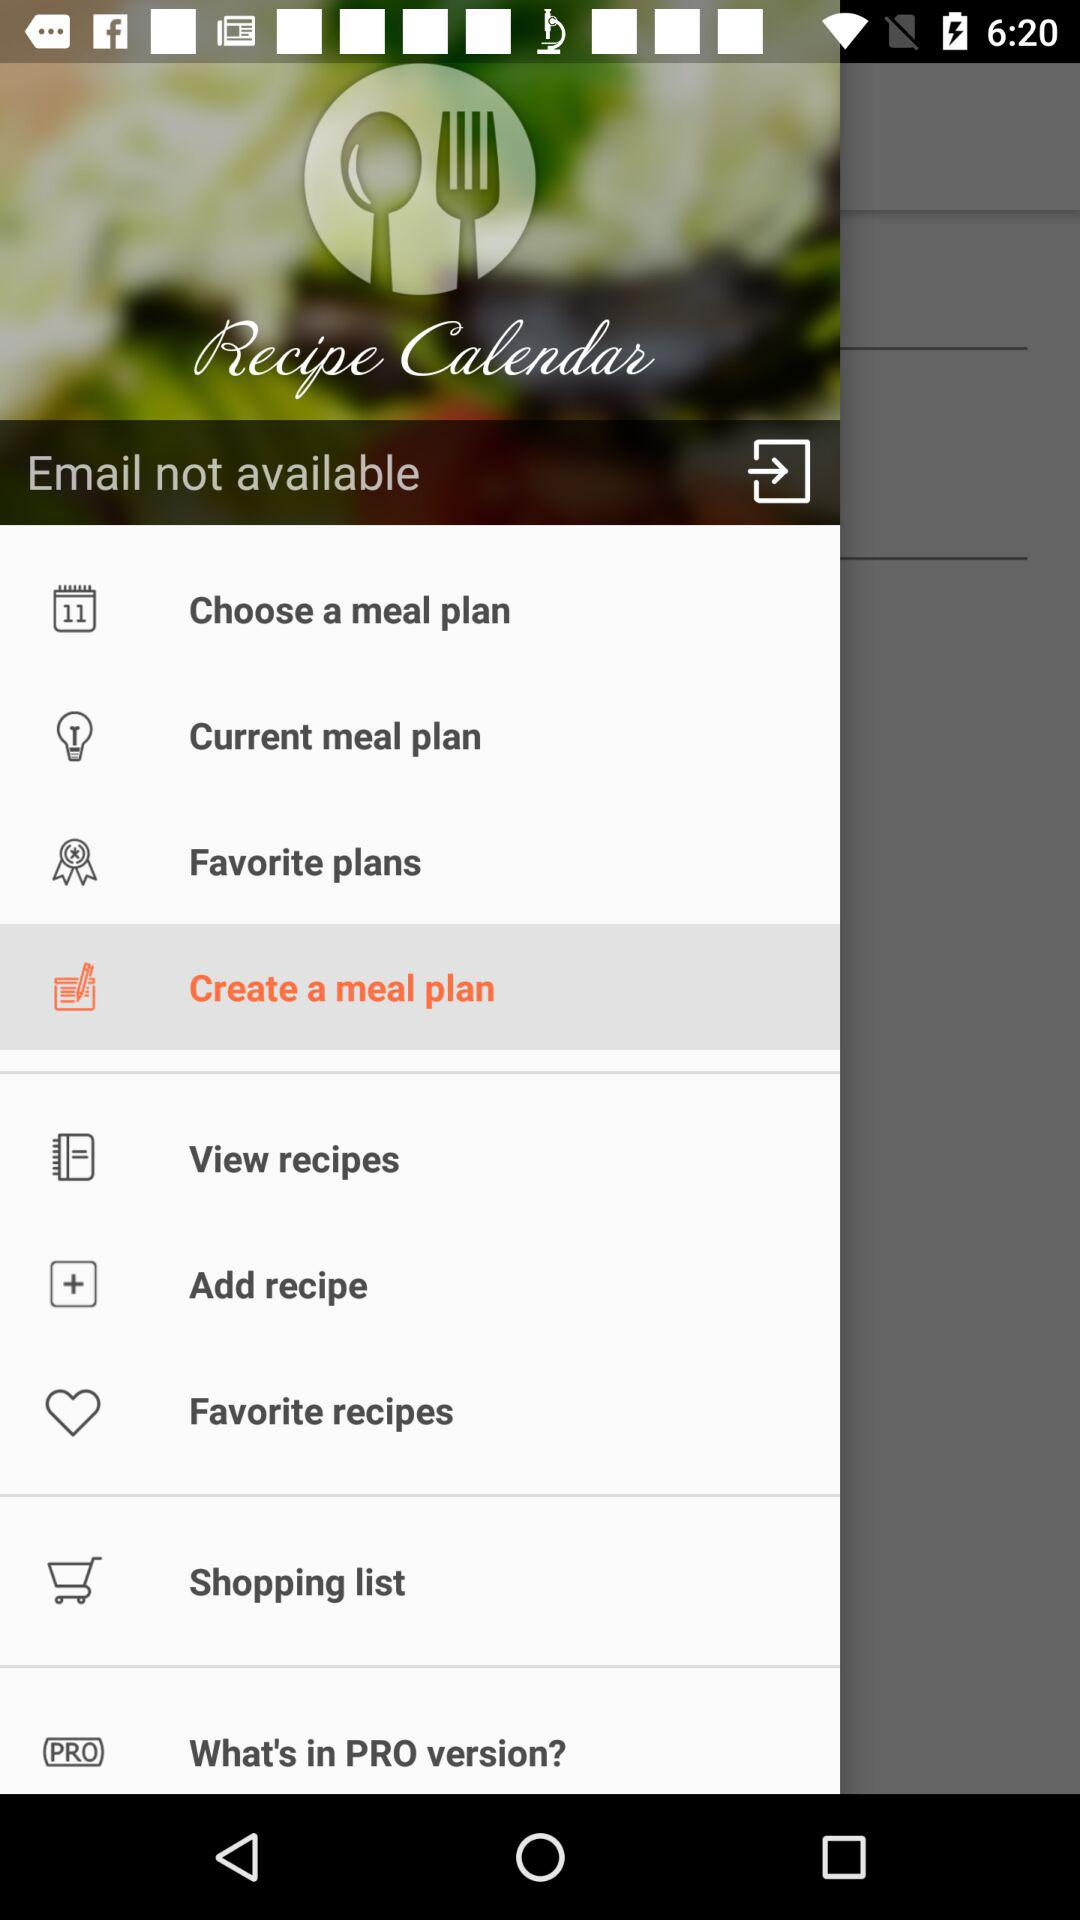Which option has been selected from the recipe calendar? The selected option is "Create a meal plan". 